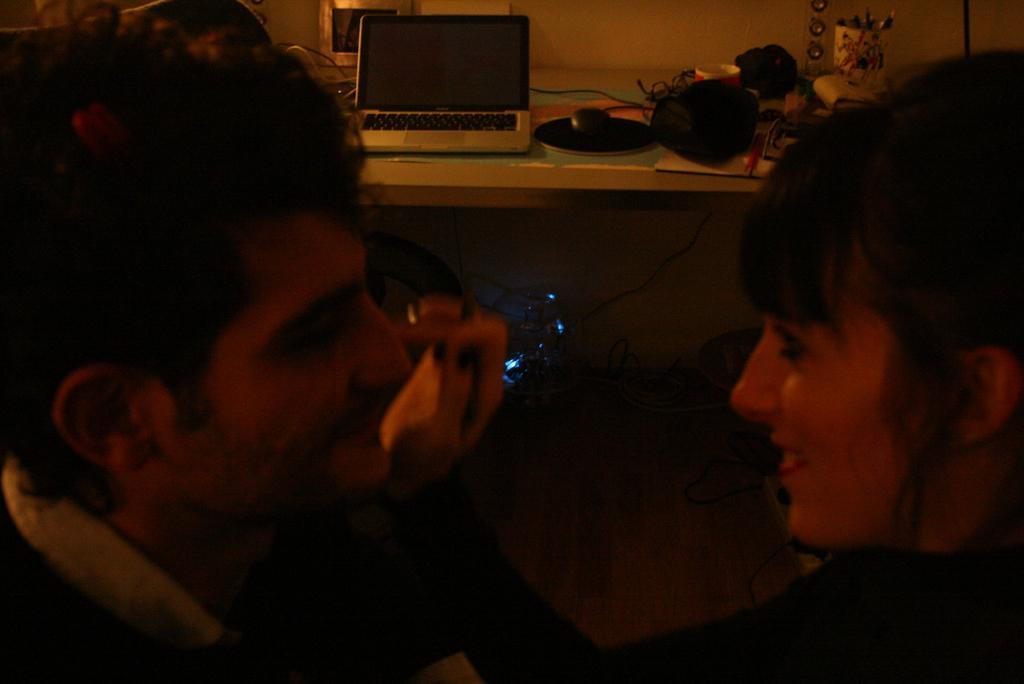In one or two sentences, can you explain what this image depicts? In this picture we can see a man and a woman smiling, laptop and some objects on a table, lights and in the background we can see the wall. 